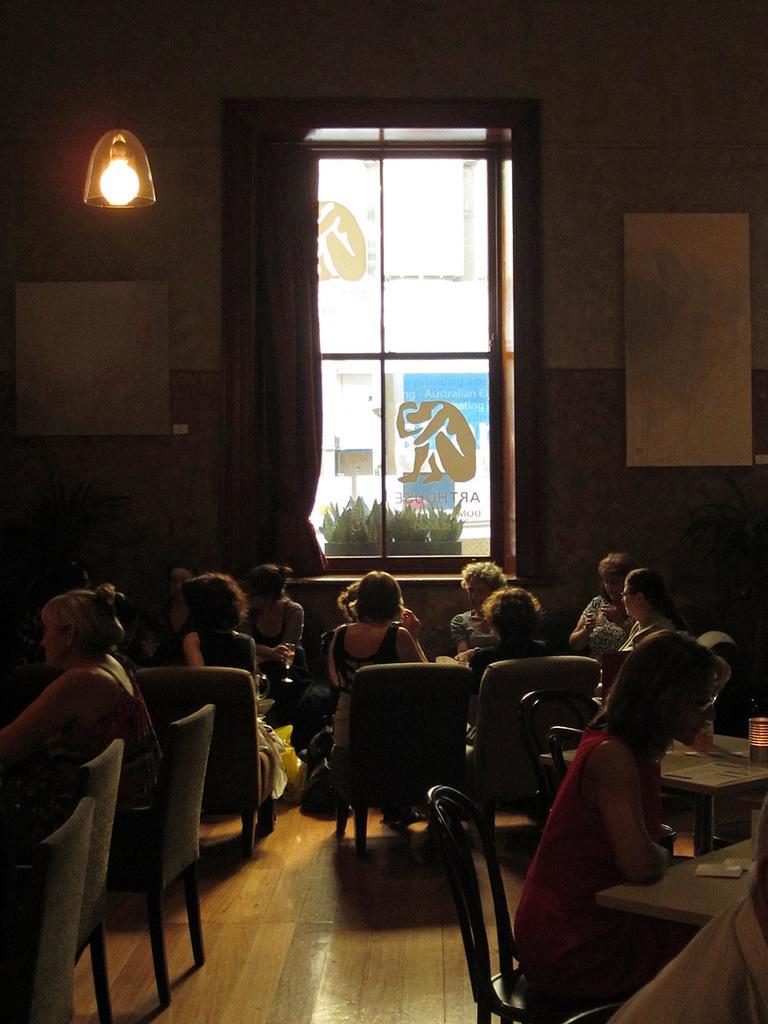Can you describe this image briefly? In this image I see number of people who are sitting on chairs and there are tables in front of them on which there are few things, I can also see this woman is holding a glass. In the background I see the wall, a window, curtain and a light over here, I can also a plant through the window. 